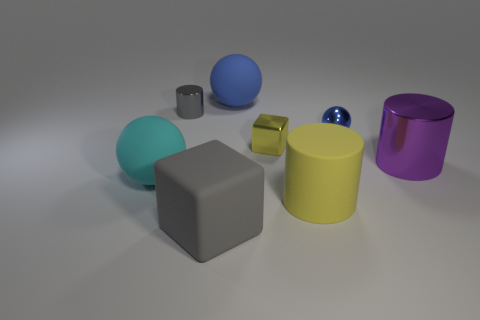What material do the objects in the image appear to be made of? The objects in the image appear to be made of a matte material for the larger shapes, like the cubes and cylinders, while the smaller spheres have a reflective, possibly metallic surface. 